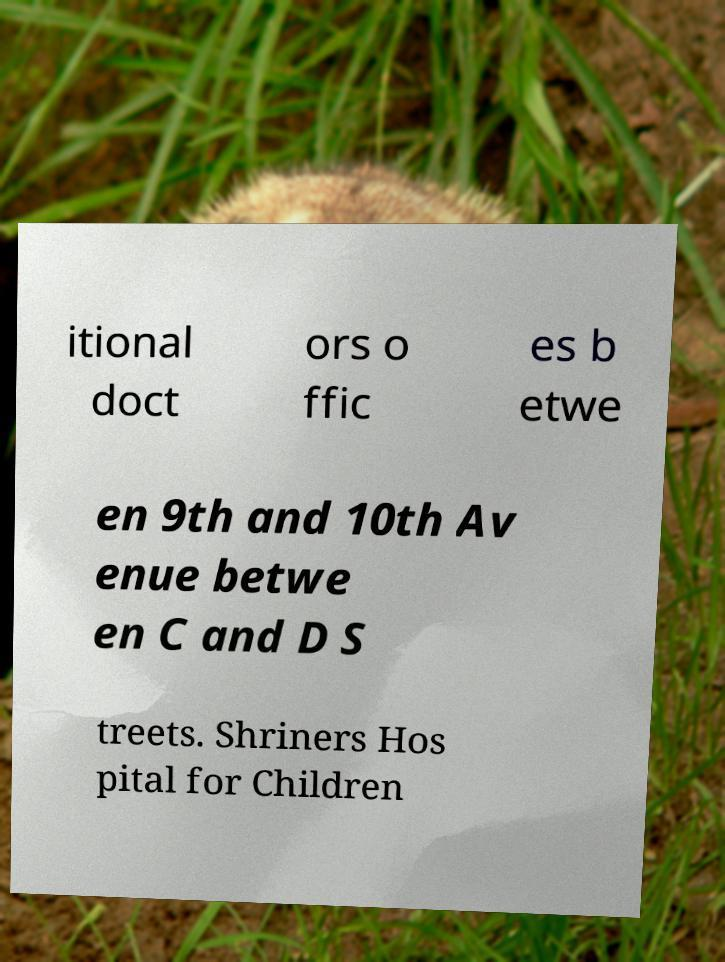I need the written content from this picture converted into text. Can you do that? itional doct ors o ffic es b etwe en 9th and 10th Av enue betwe en C and D S treets. Shriners Hos pital for Children 